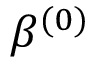Convert formula to latex. <formula><loc_0><loc_0><loc_500><loc_500>\beta ^ { ( 0 ) }</formula> 